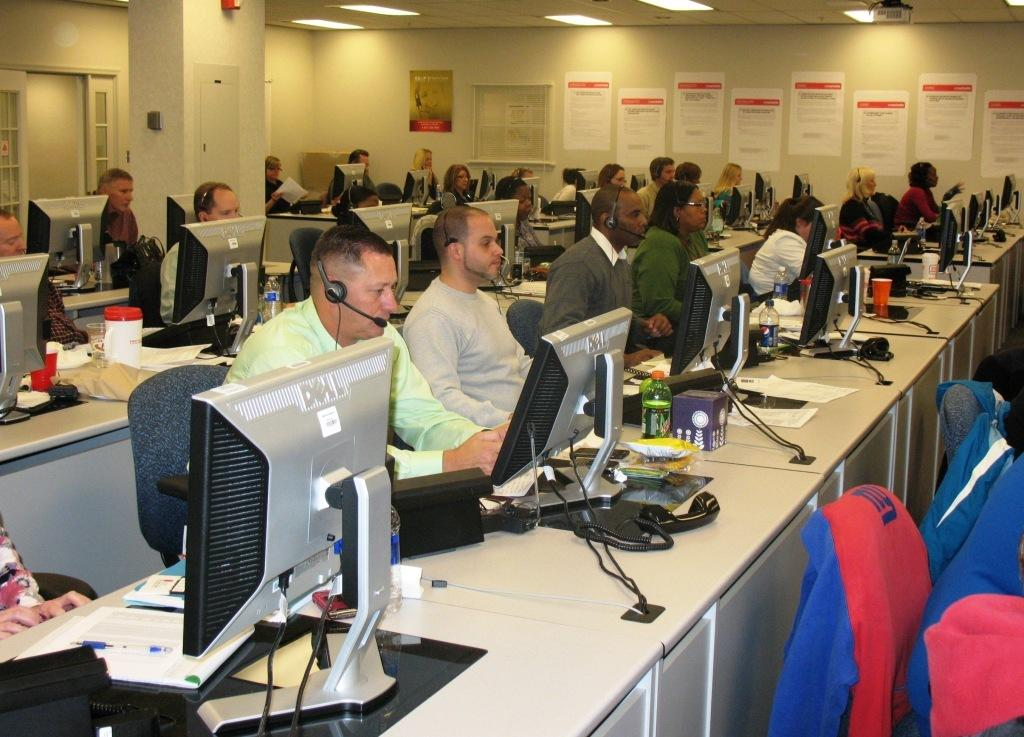<image>
Describe the image concisely. A large group of people sit with Dell computer monitors in front of them. 